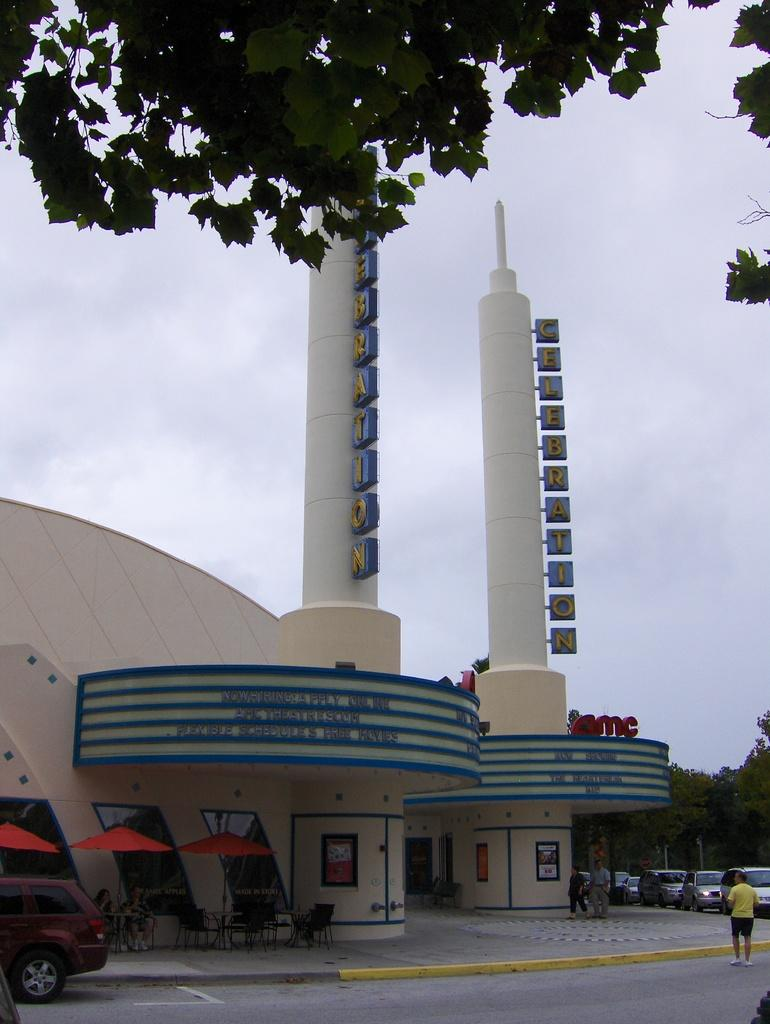What type of structure is visible in the image? There is a building in the image. What objects are present for protection from the elements? There are umbrellas in the image. What type of furniture is visible in the image? There are tables and chairs in the image. What type of vegetation is visible in the image? There are trees in the image. What type of transportation is visible in the image? There are vehicles on the road in the image. Are there any people present in the image? Yes, there are people in the image. What is visible in the background of the image? The sky is visible in the background of the image. What can be seen in the sky? There are clouds in the sky. Where is the sack located in the image? There is no sack present in the image. What type of badge is being worn by the people in the image? There is no badge visible on any of the people in the image. 